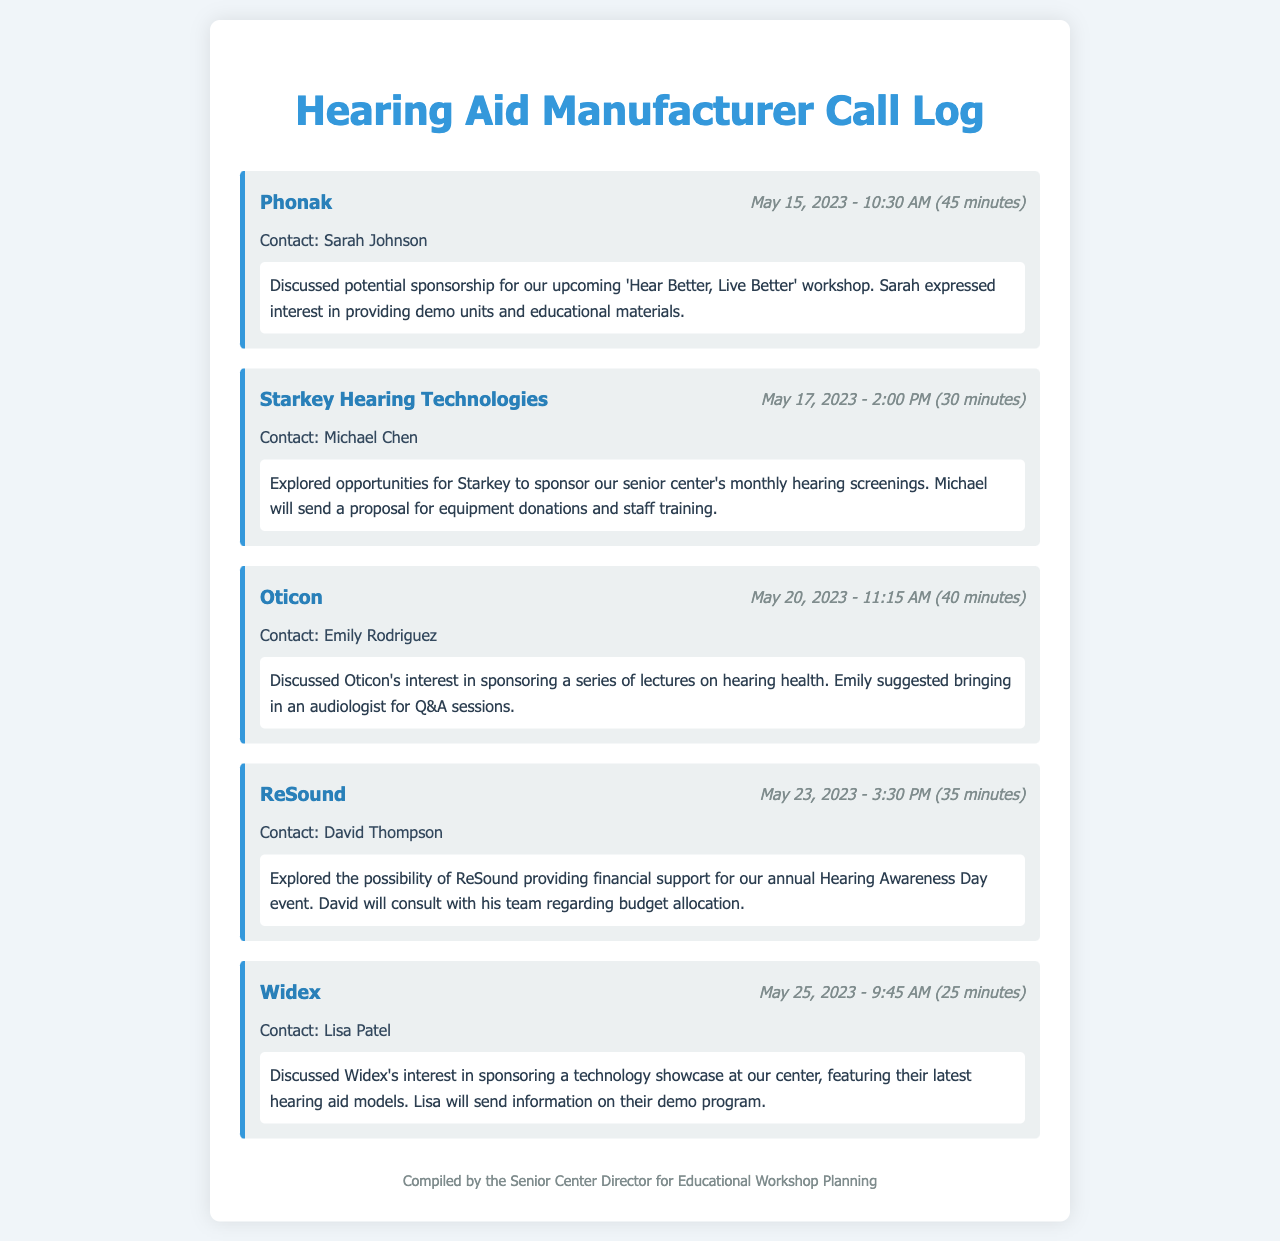What is the date of the call with Phonak? The call with Phonak took place on May 15, 2023.
Answer: May 15, 2023 Who was the contact person for Widex? The contact person for Widex was Lisa Patel.
Answer: Lisa Patel How long was the call with Starkey Hearing Technologies? The call with Starkey Hearing Technologies lasted for 30 minutes.
Answer: 30 minutes What did Emily Rodriguez suggest for Oticon's sponsorship? Emily suggested bringing in an audiologist for Q&A sessions.
Answer: Audiologist for Q&A sessions What sponsorship opportunity did ReSound explore? ReSound explored providing financial support for the annual Hearing Awareness Day event.
Answer: Financial support for Hearing Awareness Day What is the main purpose of the calls documented? The main purpose was to discuss potential sponsorship opportunities for educational workshops on hearing health.
Answer: Sponsorship opportunities for workshops Which company expressed interest in providing demo units? Phonak expressed interest in providing demo units.
Answer: Phonak How many minutes long was the call with Oticon? The call with Oticon was 40 minutes long.
Answer: 40 minutes What event is mentioned in the call with ReSound? The event mentioned is the annual Hearing Awareness Day.
Answer: Annual Hearing Awareness Day 